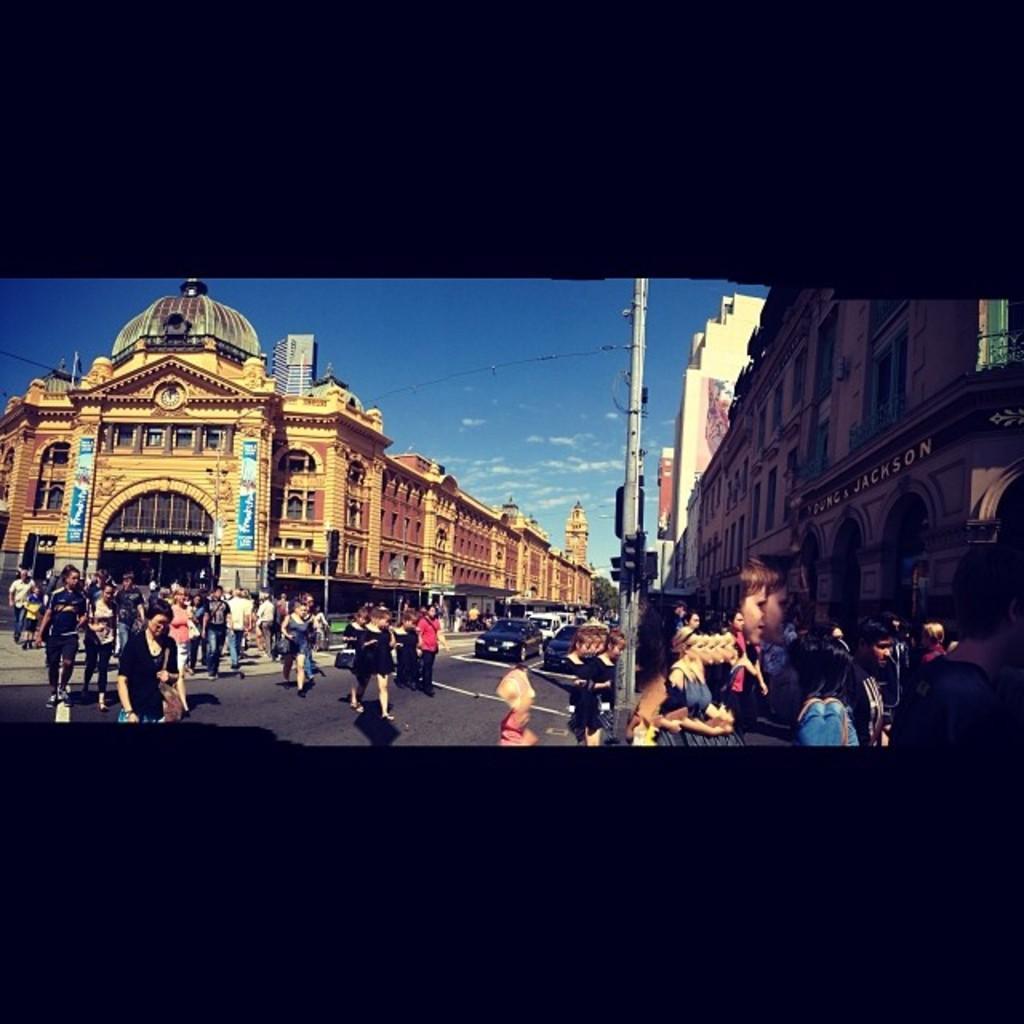In one or two sentences, can you explain what this image depicts? On the left side, there are persons and vehicles on the road. On the right side, there are persons, a pole and buildings. In the background, there are buildings and there are clouds in the blue sky. 